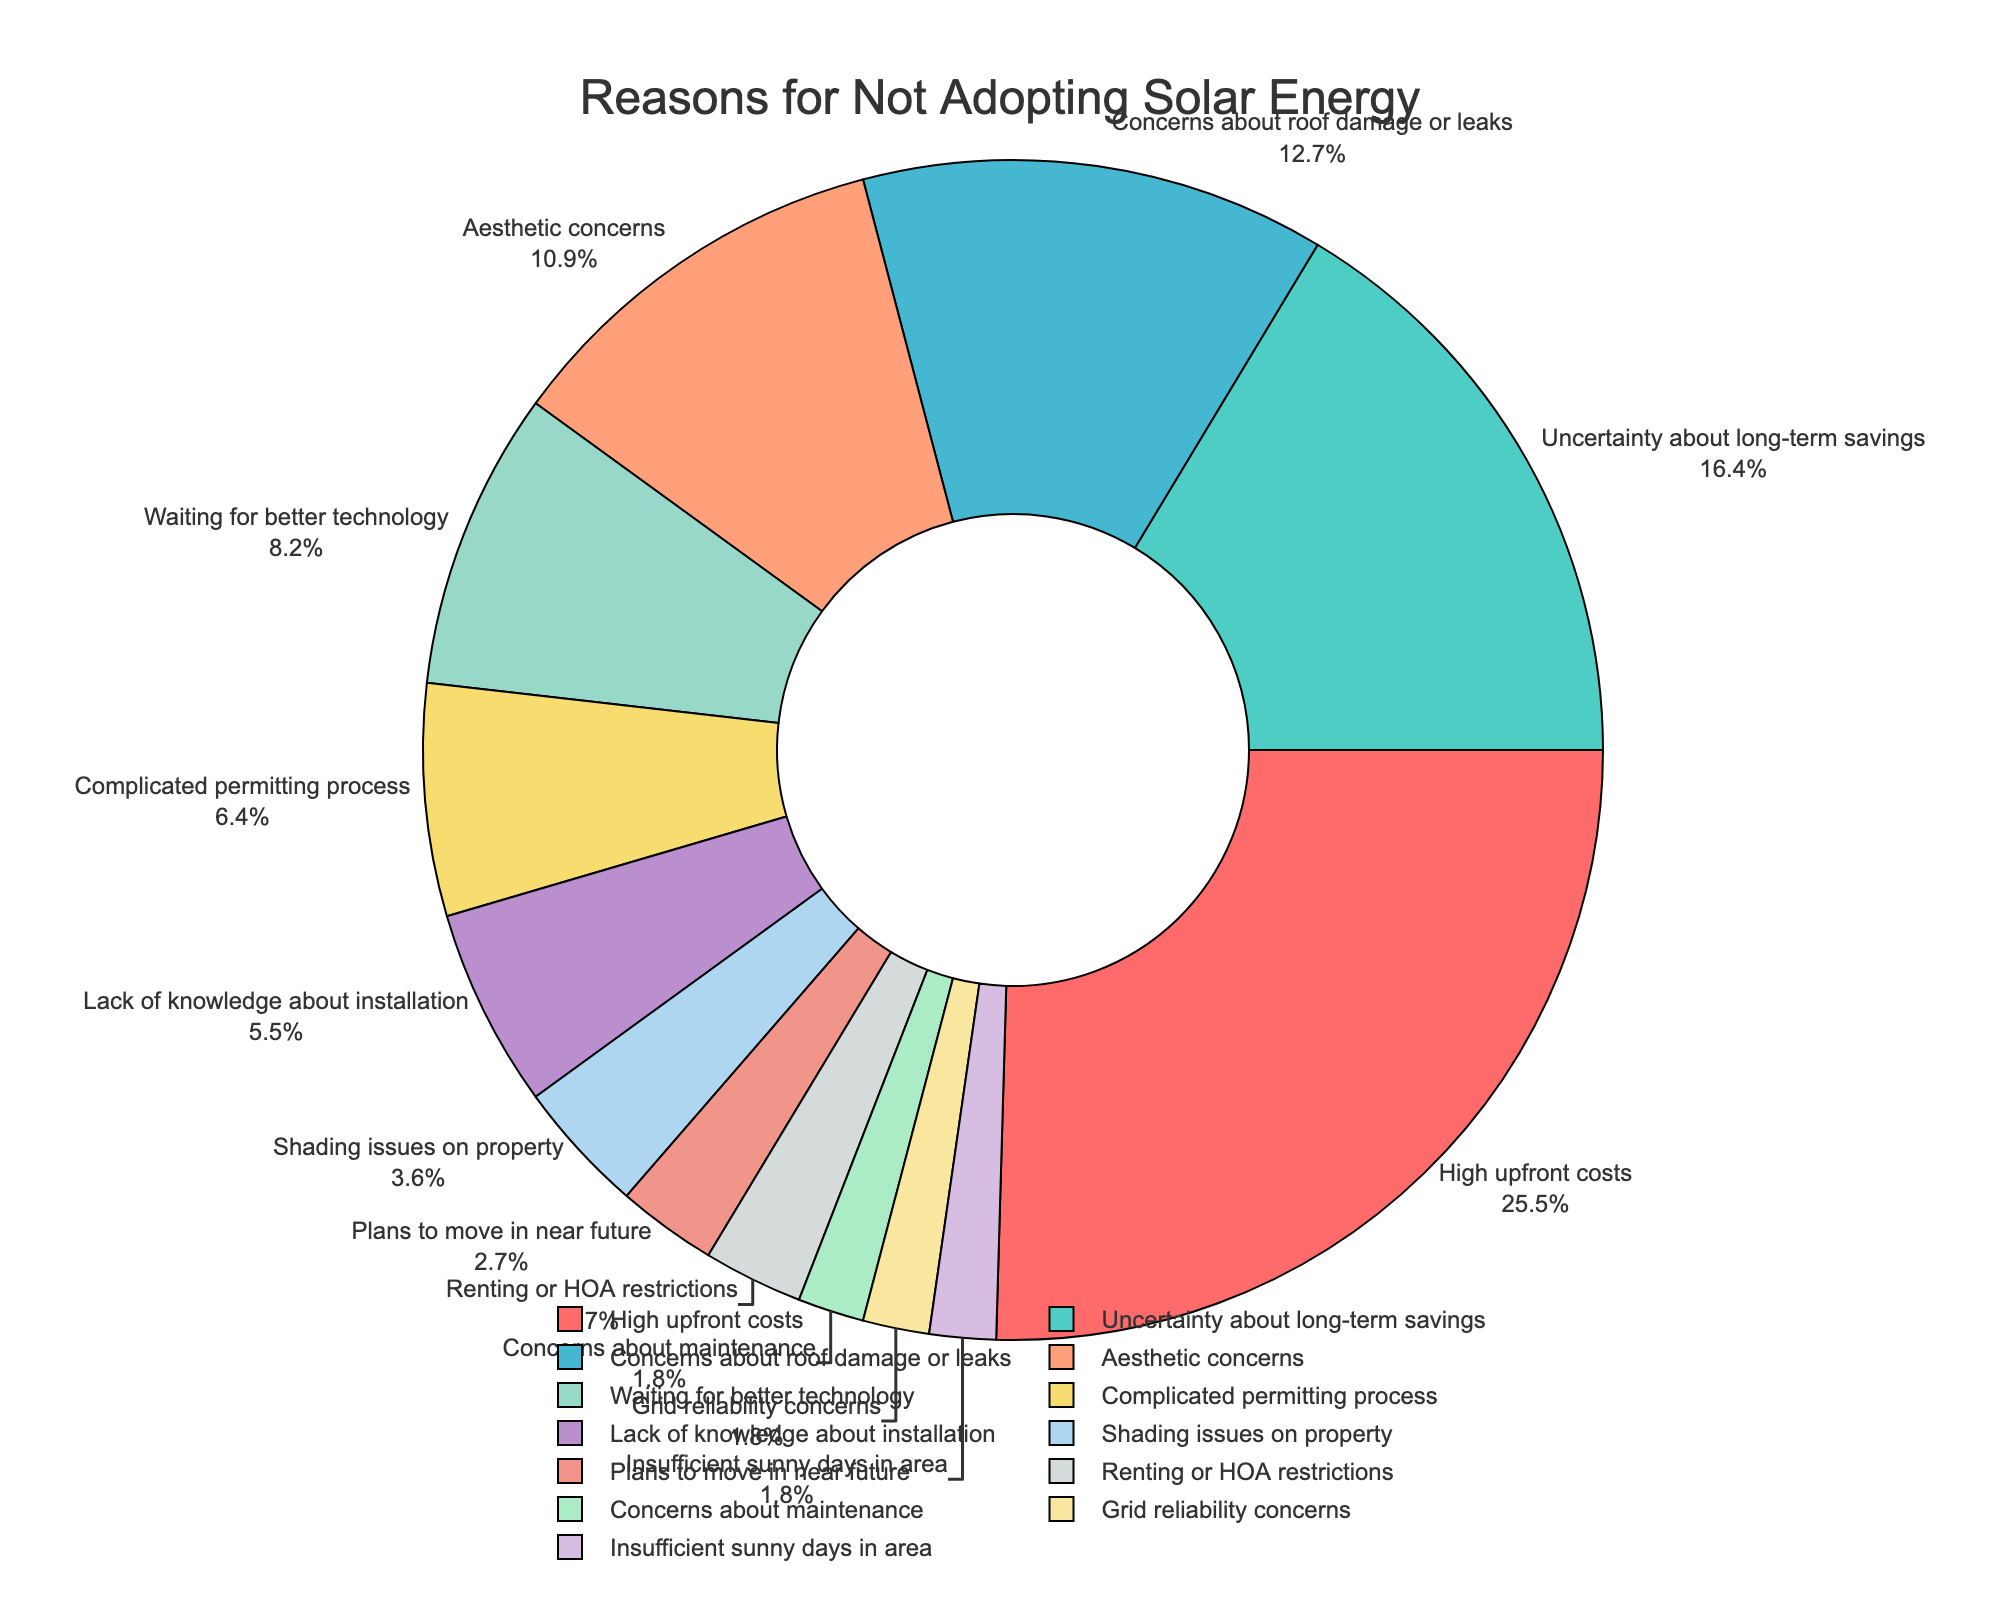What percentage of homeowners cite "High upfront costs" and "Uncertainty about long-term savings" combined? Add the percentages of "High upfront costs" (28%) and "Uncertainty about long-term savings" (18%). The combined percentage is 28% + 18% = 46%.
Answer: 46% Is "Concerns about roof damage or leaks" cited by a higher percentage of homeowners than "Aesthetic concerns"? Compare the percentages for "Concerns about roof damage or leaks" (14%) and "Aesthetic concerns" (12%). 14% is greater than 12%.
Answer: Yes Which reason is cited the least by homeowners for not adopting solar energy? Identify the reason with the smallest percentage. "Concerns about maintenance," "Grid reliability concerns," and "Insufficient sunny days in area" each have the smallest percentage (2%).
Answer: Concerns about maintenance/Grid reliability concerns/Insufficient sunny days in area What color represents "Waiting for better technology"? Identify the segment labeled "Waiting for better technology" and note its color. The color appears as a specific color in the pie chart (in this scenario, let's assume it appears as yellow).
Answer: Yellow How many reasons are cited by more than 10% of homeowners? Count the reasons with percentages greater than 10%. They are "High upfront costs" (28%), "Uncertainty about long-term savings" (18%), "Concerns about roof damage or leaks" (14%), and "Aesthetic concerns" (12%), making it 4 reasons in total.
Answer: 4 What is the total percentage of homeowners citing reasons related to costs ("High upfront costs" and "Complicated permitting process")? Sum the percentages of "High upfront costs" (28%) and "Complicated permitting process" (7%). The total percentage is 28% + 7% = 35%.
Answer: 35% How does the percentage of homeowners concerned about "Plans to move in the near future" compare to those concerned about "Renting or HOA restrictions"? Compare the percentages for "Plans to move in the near future" and "Renting or HOA restrictions," both of which are 3%.
Answer: Equal Which reasons cited by homeowners form the smallest segments in the pie chart? Identify and list the smallest segments based on their percentages. They are "Concerns about maintenance," "Grid reliability concerns," and "Insufficient sunny days in area," each with 2%.
Answer: Concerns about maintenance/Grid reliability concerns/Insufficient sunny days in area What is the combined percentage of the top three reasons cited by homeowners for not adopting solar energy? Add the percentages of the top three reasons: "High upfront costs" (28%), "Uncertainty about long-term savings" (18%), and "Concerns about roof damage or leaks" (14%). The combined percentage is 28% + 18% + 14% = 60%.
Answer: 60% 